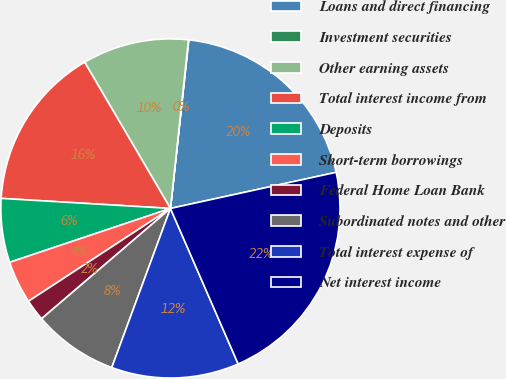Convert chart to OTSL. <chart><loc_0><loc_0><loc_500><loc_500><pie_chart><fcel>Loans and direct financing<fcel>Investment securities<fcel>Other earning assets<fcel>Total interest income from<fcel>Deposits<fcel>Short-term borrowings<fcel>Federal Home Loan Bank<fcel>Subordinated notes and other<fcel>Total interest expense of<fcel>Net interest income<nl><fcel>19.86%<fcel>0.03%<fcel>10.14%<fcel>15.61%<fcel>6.09%<fcel>4.07%<fcel>2.05%<fcel>8.11%<fcel>12.16%<fcel>21.88%<nl></chart> 